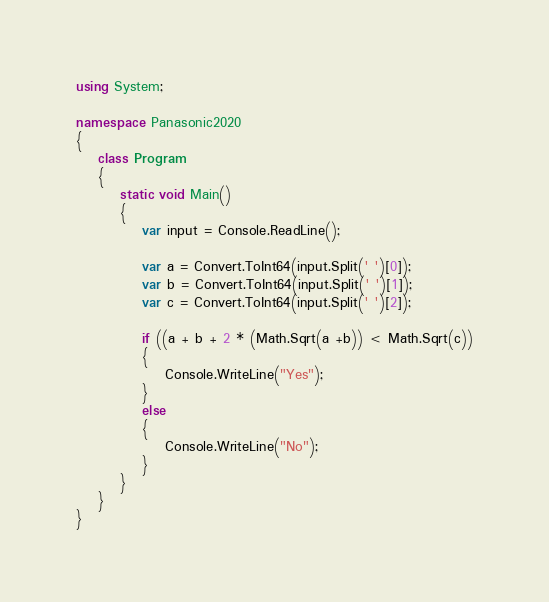<code> <loc_0><loc_0><loc_500><loc_500><_C#_>using System;

namespace Panasonic2020
{
    class Program
    {
        static void Main()
        {
            var input = Console.ReadLine();

            var a = Convert.ToInt64(input.Split(' ')[0]);
            var b = Convert.ToInt64(input.Split(' ')[1]);
            var c = Convert.ToInt64(input.Split(' ')[2]);

            if ((a + b + 2 * (Math.Sqrt(a +b)) < Math.Sqrt(c))
            {
                Console.WriteLine("Yes");
            }
            else
            {
                Console.WriteLine("No");
            }
        }
    }
}
</code> 